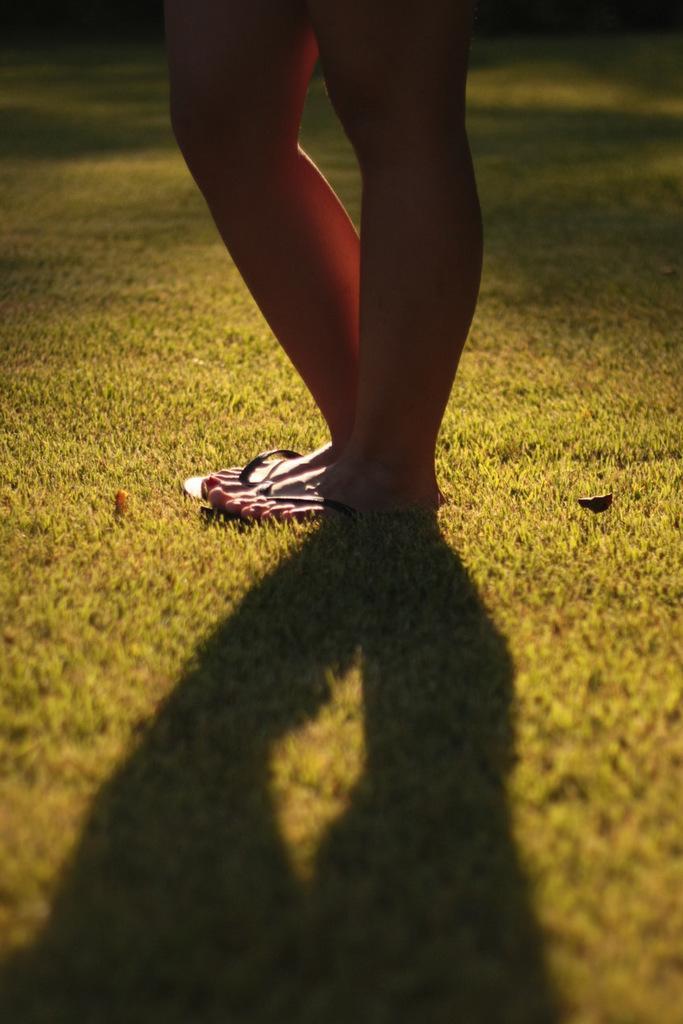In one or two sentences, can you explain what this image depicts? In this image, we can see a person wearing slippers and at the bottom, there is ground and we can see a shadow. 